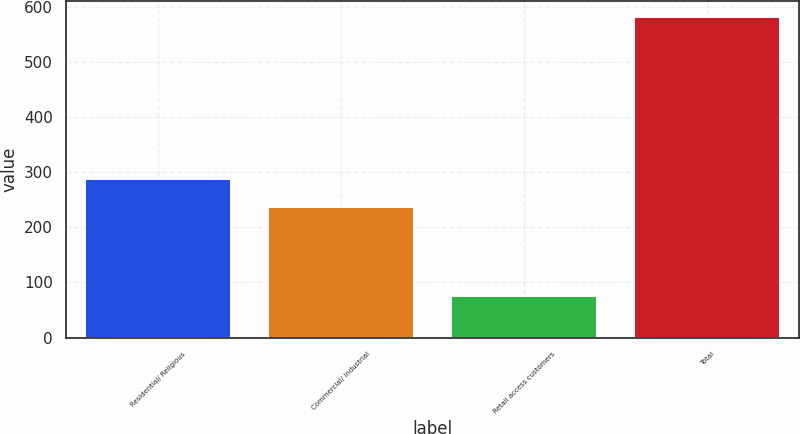Convert chart to OTSL. <chart><loc_0><loc_0><loc_500><loc_500><bar_chart><fcel>Residential/ Religious<fcel>Commercial/ Industrial<fcel>Retail access customers<fcel>Total<nl><fcel>287.6<fcel>237<fcel>76<fcel>582<nl></chart> 